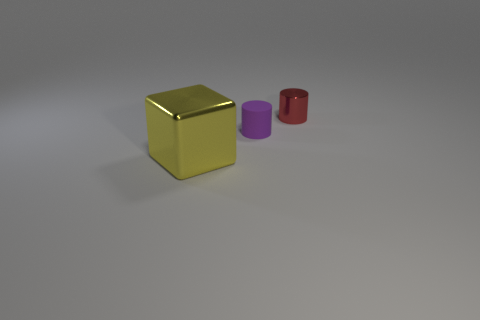How many blocks are yellow things or metal objects?
Provide a short and direct response. 1. How many things are both in front of the red metal cylinder and on the right side of the big yellow metallic block?
Give a very brief answer. 1. The metallic object behind the yellow block is what color?
Keep it short and to the point. Red. There is a red object that is made of the same material as the large cube; what is its size?
Offer a very short reply. Small. How many small cylinders are in front of the metallic thing behind the yellow thing?
Your answer should be compact. 1. There is a tiny red metallic thing; how many tiny cylinders are in front of it?
Keep it short and to the point. 1. The tiny cylinder to the left of the shiny thing on the right side of the metallic object that is in front of the tiny red object is what color?
Keep it short and to the point. Purple. Is the color of the shiny block that is in front of the small matte object the same as the small thing on the right side of the small purple cylinder?
Ensure brevity in your answer.  No. What is the shape of the small object in front of the shiny thing behind the big yellow block?
Your response must be concise. Cylinder. Are there any red cubes of the same size as the red thing?
Provide a succinct answer. No. 